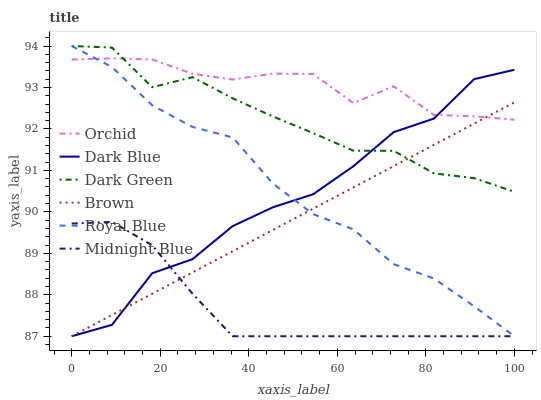Does Midnight Blue have the minimum area under the curve?
Answer yes or no. Yes. Does Orchid have the maximum area under the curve?
Answer yes or no. Yes. Does Royal Blue have the minimum area under the curve?
Answer yes or no. No. Does Royal Blue have the maximum area under the curve?
Answer yes or no. No. Is Brown the smoothest?
Answer yes or no. Yes. Is Dark Blue the roughest?
Answer yes or no. Yes. Is Midnight Blue the smoothest?
Answer yes or no. No. Is Midnight Blue the roughest?
Answer yes or no. No. Does Brown have the lowest value?
Answer yes or no. Yes. Does Orchid have the lowest value?
Answer yes or no. No. Does Dark Green have the highest value?
Answer yes or no. Yes. Does Midnight Blue have the highest value?
Answer yes or no. No. Is Midnight Blue less than Orchid?
Answer yes or no. Yes. Is Orchid greater than Midnight Blue?
Answer yes or no. Yes. Does Royal Blue intersect Midnight Blue?
Answer yes or no. Yes. Is Royal Blue less than Midnight Blue?
Answer yes or no. No. Is Royal Blue greater than Midnight Blue?
Answer yes or no. No. Does Midnight Blue intersect Orchid?
Answer yes or no. No. 